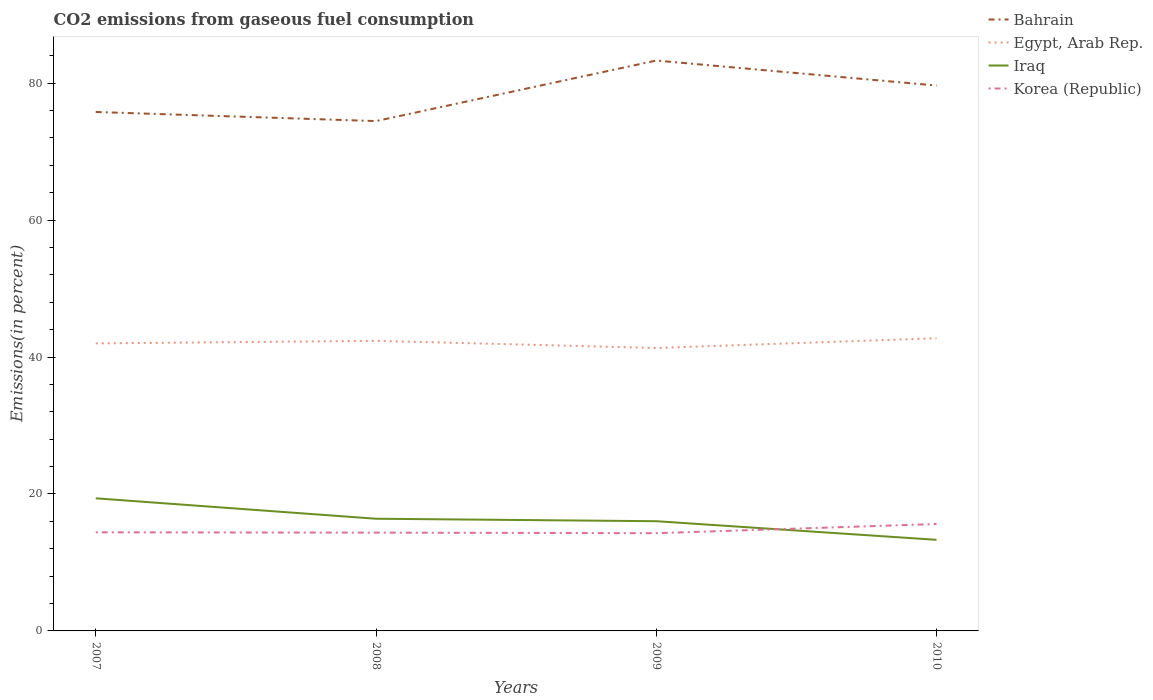How many different coloured lines are there?
Keep it short and to the point. 4. Does the line corresponding to Egypt, Arab Rep. intersect with the line corresponding to Iraq?
Provide a short and direct response. No. Across all years, what is the maximum total CO2 emitted in Egypt, Arab Rep.?
Your answer should be very brief. 41.33. What is the total total CO2 emitted in Iraq in the graph?
Provide a short and direct response. 3.08. What is the difference between the highest and the second highest total CO2 emitted in Iraq?
Provide a short and direct response. 6.06. What is the difference between the highest and the lowest total CO2 emitted in Iraq?
Your answer should be compact. 2. How many years are there in the graph?
Your answer should be compact. 4. What is the difference between two consecutive major ticks on the Y-axis?
Keep it short and to the point. 20. Does the graph contain grids?
Offer a terse response. No. Where does the legend appear in the graph?
Your answer should be compact. Top right. How are the legend labels stacked?
Your answer should be very brief. Vertical. What is the title of the graph?
Offer a very short reply. CO2 emissions from gaseous fuel consumption. What is the label or title of the Y-axis?
Your answer should be very brief. Emissions(in percent). What is the Emissions(in percent) of Bahrain in 2007?
Provide a succinct answer. 75.8. What is the Emissions(in percent) in Egypt, Arab Rep. in 2007?
Give a very brief answer. 42. What is the Emissions(in percent) in Iraq in 2007?
Offer a very short reply. 19.37. What is the Emissions(in percent) in Korea (Republic) in 2007?
Make the answer very short. 14.4. What is the Emissions(in percent) in Bahrain in 2008?
Your answer should be compact. 74.47. What is the Emissions(in percent) in Egypt, Arab Rep. in 2008?
Make the answer very short. 42.37. What is the Emissions(in percent) of Iraq in 2008?
Offer a very short reply. 16.38. What is the Emissions(in percent) of Korea (Republic) in 2008?
Ensure brevity in your answer.  14.36. What is the Emissions(in percent) of Bahrain in 2009?
Ensure brevity in your answer.  83.31. What is the Emissions(in percent) of Egypt, Arab Rep. in 2009?
Your answer should be compact. 41.33. What is the Emissions(in percent) of Iraq in 2009?
Make the answer very short. 16.03. What is the Emissions(in percent) of Korea (Republic) in 2009?
Make the answer very short. 14.27. What is the Emissions(in percent) of Bahrain in 2010?
Offer a terse response. 79.66. What is the Emissions(in percent) in Egypt, Arab Rep. in 2010?
Your answer should be compact. 42.75. What is the Emissions(in percent) in Iraq in 2010?
Your answer should be compact. 13.31. What is the Emissions(in percent) in Korea (Republic) in 2010?
Ensure brevity in your answer.  15.61. Across all years, what is the maximum Emissions(in percent) of Bahrain?
Offer a very short reply. 83.31. Across all years, what is the maximum Emissions(in percent) in Egypt, Arab Rep.?
Make the answer very short. 42.75. Across all years, what is the maximum Emissions(in percent) in Iraq?
Your answer should be very brief. 19.37. Across all years, what is the maximum Emissions(in percent) of Korea (Republic)?
Provide a short and direct response. 15.61. Across all years, what is the minimum Emissions(in percent) in Bahrain?
Provide a short and direct response. 74.47. Across all years, what is the minimum Emissions(in percent) of Egypt, Arab Rep.?
Make the answer very short. 41.33. Across all years, what is the minimum Emissions(in percent) of Iraq?
Provide a succinct answer. 13.31. Across all years, what is the minimum Emissions(in percent) of Korea (Republic)?
Your answer should be compact. 14.27. What is the total Emissions(in percent) of Bahrain in the graph?
Give a very brief answer. 313.23. What is the total Emissions(in percent) of Egypt, Arab Rep. in the graph?
Make the answer very short. 168.44. What is the total Emissions(in percent) in Iraq in the graph?
Your answer should be very brief. 65.08. What is the total Emissions(in percent) of Korea (Republic) in the graph?
Make the answer very short. 58.64. What is the difference between the Emissions(in percent) in Bahrain in 2007 and that in 2008?
Keep it short and to the point. 1.33. What is the difference between the Emissions(in percent) in Egypt, Arab Rep. in 2007 and that in 2008?
Make the answer very short. -0.37. What is the difference between the Emissions(in percent) in Iraq in 2007 and that in 2008?
Your answer should be very brief. 2.98. What is the difference between the Emissions(in percent) in Korea (Republic) in 2007 and that in 2008?
Give a very brief answer. 0.04. What is the difference between the Emissions(in percent) in Bahrain in 2007 and that in 2009?
Provide a short and direct response. -7.51. What is the difference between the Emissions(in percent) in Egypt, Arab Rep. in 2007 and that in 2009?
Offer a very short reply. 0.67. What is the difference between the Emissions(in percent) of Iraq in 2007 and that in 2009?
Keep it short and to the point. 3.34. What is the difference between the Emissions(in percent) of Korea (Republic) in 2007 and that in 2009?
Your response must be concise. 0.13. What is the difference between the Emissions(in percent) in Bahrain in 2007 and that in 2010?
Provide a short and direct response. -3.86. What is the difference between the Emissions(in percent) of Egypt, Arab Rep. in 2007 and that in 2010?
Your answer should be compact. -0.75. What is the difference between the Emissions(in percent) in Iraq in 2007 and that in 2010?
Offer a terse response. 6.06. What is the difference between the Emissions(in percent) in Korea (Republic) in 2007 and that in 2010?
Provide a short and direct response. -1.22. What is the difference between the Emissions(in percent) in Bahrain in 2008 and that in 2009?
Ensure brevity in your answer.  -8.84. What is the difference between the Emissions(in percent) in Egypt, Arab Rep. in 2008 and that in 2009?
Your response must be concise. 1.04. What is the difference between the Emissions(in percent) of Iraq in 2008 and that in 2009?
Give a very brief answer. 0.36. What is the difference between the Emissions(in percent) in Korea (Republic) in 2008 and that in 2009?
Your answer should be compact. 0.08. What is the difference between the Emissions(in percent) in Bahrain in 2008 and that in 2010?
Offer a very short reply. -5.19. What is the difference between the Emissions(in percent) of Egypt, Arab Rep. in 2008 and that in 2010?
Your answer should be very brief. -0.38. What is the difference between the Emissions(in percent) in Iraq in 2008 and that in 2010?
Your answer should be compact. 3.08. What is the difference between the Emissions(in percent) in Korea (Republic) in 2008 and that in 2010?
Keep it short and to the point. -1.26. What is the difference between the Emissions(in percent) of Bahrain in 2009 and that in 2010?
Provide a short and direct response. 3.65. What is the difference between the Emissions(in percent) in Egypt, Arab Rep. in 2009 and that in 2010?
Your response must be concise. -1.42. What is the difference between the Emissions(in percent) in Iraq in 2009 and that in 2010?
Your answer should be very brief. 2.72. What is the difference between the Emissions(in percent) in Korea (Republic) in 2009 and that in 2010?
Offer a very short reply. -1.34. What is the difference between the Emissions(in percent) of Bahrain in 2007 and the Emissions(in percent) of Egypt, Arab Rep. in 2008?
Give a very brief answer. 33.43. What is the difference between the Emissions(in percent) of Bahrain in 2007 and the Emissions(in percent) of Iraq in 2008?
Ensure brevity in your answer.  59.41. What is the difference between the Emissions(in percent) of Bahrain in 2007 and the Emissions(in percent) of Korea (Republic) in 2008?
Your answer should be compact. 61.44. What is the difference between the Emissions(in percent) in Egypt, Arab Rep. in 2007 and the Emissions(in percent) in Iraq in 2008?
Provide a short and direct response. 25.61. What is the difference between the Emissions(in percent) in Egypt, Arab Rep. in 2007 and the Emissions(in percent) in Korea (Republic) in 2008?
Keep it short and to the point. 27.64. What is the difference between the Emissions(in percent) of Iraq in 2007 and the Emissions(in percent) of Korea (Republic) in 2008?
Make the answer very short. 5.01. What is the difference between the Emissions(in percent) in Bahrain in 2007 and the Emissions(in percent) in Egypt, Arab Rep. in 2009?
Your answer should be very brief. 34.47. What is the difference between the Emissions(in percent) of Bahrain in 2007 and the Emissions(in percent) of Iraq in 2009?
Offer a very short reply. 59.77. What is the difference between the Emissions(in percent) in Bahrain in 2007 and the Emissions(in percent) in Korea (Republic) in 2009?
Your response must be concise. 61.52. What is the difference between the Emissions(in percent) in Egypt, Arab Rep. in 2007 and the Emissions(in percent) in Iraq in 2009?
Offer a very short reply. 25.97. What is the difference between the Emissions(in percent) of Egypt, Arab Rep. in 2007 and the Emissions(in percent) of Korea (Republic) in 2009?
Offer a terse response. 27.72. What is the difference between the Emissions(in percent) in Iraq in 2007 and the Emissions(in percent) in Korea (Republic) in 2009?
Your answer should be very brief. 5.1. What is the difference between the Emissions(in percent) of Bahrain in 2007 and the Emissions(in percent) of Egypt, Arab Rep. in 2010?
Make the answer very short. 33.05. What is the difference between the Emissions(in percent) in Bahrain in 2007 and the Emissions(in percent) in Iraq in 2010?
Keep it short and to the point. 62.49. What is the difference between the Emissions(in percent) of Bahrain in 2007 and the Emissions(in percent) of Korea (Republic) in 2010?
Offer a very short reply. 60.18. What is the difference between the Emissions(in percent) in Egypt, Arab Rep. in 2007 and the Emissions(in percent) in Iraq in 2010?
Give a very brief answer. 28.69. What is the difference between the Emissions(in percent) in Egypt, Arab Rep. in 2007 and the Emissions(in percent) in Korea (Republic) in 2010?
Your response must be concise. 26.38. What is the difference between the Emissions(in percent) of Iraq in 2007 and the Emissions(in percent) of Korea (Republic) in 2010?
Your answer should be very brief. 3.75. What is the difference between the Emissions(in percent) in Bahrain in 2008 and the Emissions(in percent) in Egypt, Arab Rep. in 2009?
Keep it short and to the point. 33.14. What is the difference between the Emissions(in percent) in Bahrain in 2008 and the Emissions(in percent) in Iraq in 2009?
Your answer should be very brief. 58.44. What is the difference between the Emissions(in percent) in Bahrain in 2008 and the Emissions(in percent) in Korea (Republic) in 2009?
Ensure brevity in your answer.  60.19. What is the difference between the Emissions(in percent) in Egypt, Arab Rep. in 2008 and the Emissions(in percent) in Iraq in 2009?
Your answer should be compact. 26.34. What is the difference between the Emissions(in percent) in Egypt, Arab Rep. in 2008 and the Emissions(in percent) in Korea (Republic) in 2009?
Provide a short and direct response. 28.1. What is the difference between the Emissions(in percent) of Iraq in 2008 and the Emissions(in percent) of Korea (Republic) in 2009?
Your answer should be compact. 2.11. What is the difference between the Emissions(in percent) in Bahrain in 2008 and the Emissions(in percent) in Egypt, Arab Rep. in 2010?
Provide a succinct answer. 31.72. What is the difference between the Emissions(in percent) in Bahrain in 2008 and the Emissions(in percent) in Iraq in 2010?
Provide a short and direct response. 61.16. What is the difference between the Emissions(in percent) of Bahrain in 2008 and the Emissions(in percent) of Korea (Republic) in 2010?
Make the answer very short. 58.85. What is the difference between the Emissions(in percent) of Egypt, Arab Rep. in 2008 and the Emissions(in percent) of Iraq in 2010?
Make the answer very short. 29.06. What is the difference between the Emissions(in percent) of Egypt, Arab Rep. in 2008 and the Emissions(in percent) of Korea (Republic) in 2010?
Your answer should be compact. 26.75. What is the difference between the Emissions(in percent) of Iraq in 2008 and the Emissions(in percent) of Korea (Republic) in 2010?
Offer a terse response. 0.77. What is the difference between the Emissions(in percent) in Bahrain in 2009 and the Emissions(in percent) in Egypt, Arab Rep. in 2010?
Provide a short and direct response. 40.56. What is the difference between the Emissions(in percent) of Bahrain in 2009 and the Emissions(in percent) of Iraq in 2010?
Ensure brevity in your answer.  70. What is the difference between the Emissions(in percent) of Bahrain in 2009 and the Emissions(in percent) of Korea (Republic) in 2010?
Offer a very short reply. 67.69. What is the difference between the Emissions(in percent) in Egypt, Arab Rep. in 2009 and the Emissions(in percent) in Iraq in 2010?
Your answer should be very brief. 28.02. What is the difference between the Emissions(in percent) in Egypt, Arab Rep. in 2009 and the Emissions(in percent) in Korea (Republic) in 2010?
Give a very brief answer. 25.71. What is the difference between the Emissions(in percent) in Iraq in 2009 and the Emissions(in percent) in Korea (Republic) in 2010?
Keep it short and to the point. 0.41. What is the average Emissions(in percent) in Bahrain per year?
Offer a very short reply. 78.31. What is the average Emissions(in percent) of Egypt, Arab Rep. per year?
Your response must be concise. 42.11. What is the average Emissions(in percent) in Iraq per year?
Make the answer very short. 16.27. What is the average Emissions(in percent) of Korea (Republic) per year?
Your answer should be compact. 14.66. In the year 2007, what is the difference between the Emissions(in percent) in Bahrain and Emissions(in percent) in Egypt, Arab Rep.?
Your answer should be compact. 33.8. In the year 2007, what is the difference between the Emissions(in percent) in Bahrain and Emissions(in percent) in Iraq?
Your response must be concise. 56.43. In the year 2007, what is the difference between the Emissions(in percent) of Bahrain and Emissions(in percent) of Korea (Republic)?
Provide a succinct answer. 61.4. In the year 2007, what is the difference between the Emissions(in percent) of Egypt, Arab Rep. and Emissions(in percent) of Iraq?
Offer a terse response. 22.63. In the year 2007, what is the difference between the Emissions(in percent) of Egypt, Arab Rep. and Emissions(in percent) of Korea (Republic)?
Provide a short and direct response. 27.6. In the year 2007, what is the difference between the Emissions(in percent) in Iraq and Emissions(in percent) in Korea (Republic)?
Provide a short and direct response. 4.97. In the year 2008, what is the difference between the Emissions(in percent) of Bahrain and Emissions(in percent) of Egypt, Arab Rep.?
Make the answer very short. 32.1. In the year 2008, what is the difference between the Emissions(in percent) of Bahrain and Emissions(in percent) of Iraq?
Your response must be concise. 58.08. In the year 2008, what is the difference between the Emissions(in percent) in Bahrain and Emissions(in percent) in Korea (Republic)?
Give a very brief answer. 60.11. In the year 2008, what is the difference between the Emissions(in percent) in Egypt, Arab Rep. and Emissions(in percent) in Iraq?
Your response must be concise. 25.98. In the year 2008, what is the difference between the Emissions(in percent) of Egypt, Arab Rep. and Emissions(in percent) of Korea (Republic)?
Your answer should be very brief. 28.01. In the year 2008, what is the difference between the Emissions(in percent) in Iraq and Emissions(in percent) in Korea (Republic)?
Provide a succinct answer. 2.03. In the year 2009, what is the difference between the Emissions(in percent) in Bahrain and Emissions(in percent) in Egypt, Arab Rep.?
Your response must be concise. 41.98. In the year 2009, what is the difference between the Emissions(in percent) in Bahrain and Emissions(in percent) in Iraq?
Ensure brevity in your answer.  67.28. In the year 2009, what is the difference between the Emissions(in percent) of Bahrain and Emissions(in percent) of Korea (Republic)?
Make the answer very short. 69.03. In the year 2009, what is the difference between the Emissions(in percent) in Egypt, Arab Rep. and Emissions(in percent) in Iraq?
Your answer should be compact. 25.3. In the year 2009, what is the difference between the Emissions(in percent) in Egypt, Arab Rep. and Emissions(in percent) in Korea (Republic)?
Provide a succinct answer. 27.05. In the year 2009, what is the difference between the Emissions(in percent) in Iraq and Emissions(in percent) in Korea (Republic)?
Give a very brief answer. 1.75. In the year 2010, what is the difference between the Emissions(in percent) of Bahrain and Emissions(in percent) of Egypt, Arab Rep.?
Your response must be concise. 36.91. In the year 2010, what is the difference between the Emissions(in percent) of Bahrain and Emissions(in percent) of Iraq?
Make the answer very short. 66.35. In the year 2010, what is the difference between the Emissions(in percent) of Bahrain and Emissions(in percent) of Korea (Republic)?
Offer a terse response. 64.04. In the year 2010, what is the difference between the Emissions(in percent) of Egypt, Arab Rep. and Emissions(in percent) of Iraq?
Provide a succinct answer. 29.44. In the year 2010, what is the difference between the Emissions(in percent) of Egypt, Arab Rep. and Emissions(in percent) of Korea (Republic)?
Provide a succinct answer. 27.13. In the year 2010, what is the difference between the Emissions(in percent) of Iraq and Emissions(in percent) of Korea (Republic)?
Offer a very short reply. -2.31. What is the ratio of the Emissions(in percent) in Bahrain in 2007 to that in 2008?
Give a very brief answer. 1.02. What is the ratio of the Emissions(in percent) of Egypt, Arab Rep. in 2007 to that in 2008?
Offer a terse response. 0.99. What is the ratio of the Emissions(in percent) of Iraq in 2007 to that in 2008?
Your answer should be very brief. 1.18. What is the ratio of the Emissions(in percent) in Bahrain in 2007 to that in 2009?
Your response must be concise. 0.91. What is the ratio of the Emissions(in percent) in Egypt, Arab Rep. in 2007 to that in 2009?
Offer a terse response. 1.02. What is the ratio of the Emissions(in percent) of Iraq in 2007 to that in 2009?
Your answer should be compact. 1.21. What is the ratio of the Emissions(in percent) of Korea (Republic) in 2007 to that in 2009?
Provide a short and direct response. 1.01. What is the ratio of the Emissions(in percent) in Bahrain in 2007 to that in 2010?
Offer a very short reply. 0.95. What is the ratio of the Emissions(in percent) in Egypt, Arab Rep. in 2007 to that in 2010?
Your answer should be compact. 0.98. What is the ratio of the Emissions(in percent) in Iraq in 2007 to that in 2010?
Offer a terse response. 1.46. What is the ratio of the Emissions(in percent) in Korea (Republic) in 2007 to that in 2010?
Make the answer very short. 0.92. What is the ratio of the Emissions(in percent) of Bahrain in 2008 to that in 2009?
Your answer should be very brief. 0.89. What is the ratio of the Emissions(in percent) in Egypt, Arab Rep. in 2008 to that in 2009?
Make the answer very short. 1.03. What is the ratio of the Emissions(in percent) of Iraq in 2008 to that in 2009?
Make the answer very short. 1.02. What is the ratio of the Emissions(in percent) in Bahrain in 2008 to that in 2010?
Offer a terse response. 0.93. What is the ratio of the Emissions(in percent) of Iraq in 2008 to that in 2010?
Provide a succinct answer. 1.23. What is the ratio of the Emissions(in percent) in Korea (Republic) in 2008 to that in 2010?
Give a very brief answer. 0.92. What is the ratio of the Emissions(in percent) of Bahrain in 2009 to that in 2010?
Your answer should be compact. 1.05. What is the ratio of the Emissions(in percent) of Egypt, Arab Rep. in 2009 to that in 2010?
Ensure brevity in your answer.  0.97. What is the ratio of the Emissions(in percent) in Iraq in 2009 to that in 2010?
Offer a terse response. 1.2. What is the ratio of the Emissions(in percent) of Korea (Republic) in 2009 to that in 2010?
Ensure brevity in your answer.  0.91. What is the difference between the highest and the second highest Emissions(in percent) in Bahrain?
Make the answer very short. 3.65. What is the difference between the highest and the second highest Emissions(in percent) of Egypt, Arab Rep.?
Provide a short and direct response. 0.38. What is the difference between the highest and the second highest Emissions(in percent) in Iraq?
Provide a short and direct response. 2.98. What is the difference between the highest and the second highest Emissions(in percent) of Korea (Republic)?
Make the answer very short. 1.22. What is the difference between the highest and the lowest Emissions(in percent) in Bahrain?
Your answer should be very brief. 8.84. What is the difference between the highest and the lowest Emissions(in percent) in Egypt, Arab Rep.?
Provide a succinct answer. 1.42. What is the difference between the highest and the lowest Emissions(in percent) in Iraq?
Offer a terse response. 6.06. What is the difference between the highest and the lowest Emissions(in percent) in Korea (Republic)?
Your answer should be very brief. 1.34. 